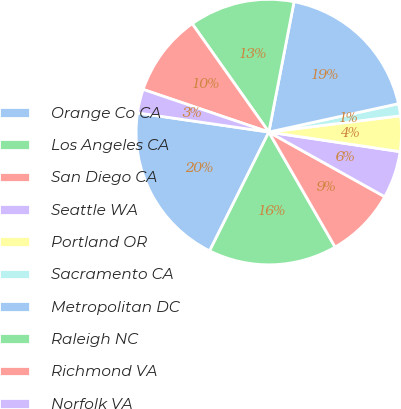<chart> <loc_0><loc_0><loc_500><loc_500><pie_chart><fcel>Orange Co CA<fcel>Los Angeles CA<fcel>San Diego CA<fcel>Seattle WA<fcel>Portland OR<fcel>Sacramento CA<fcel>Metropolitan DC<fcel>Raleigh NC<fcel>Richmond VA<fcel>Norfolk VA<nl><fcel>19.95%<fcel>15.68%<fcel>8.58%<fcel>5.74%<fcel>4.32%<fcel>1.47%<fcel>18.53%<fcel>12.84%<fcel>10.0%<fcel>2.9%<nl></chart> 